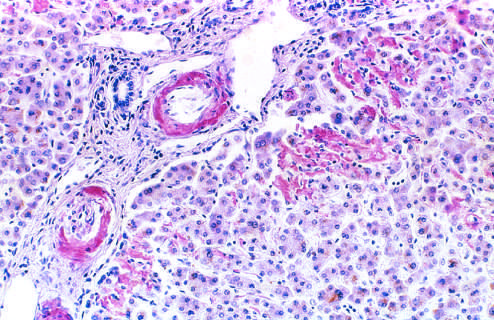what reveals pink-red deposits of amyloid in the walls of blood vessels and along sinusoids?
Answer the question using a single word or phrase. A section liver stained with congo 